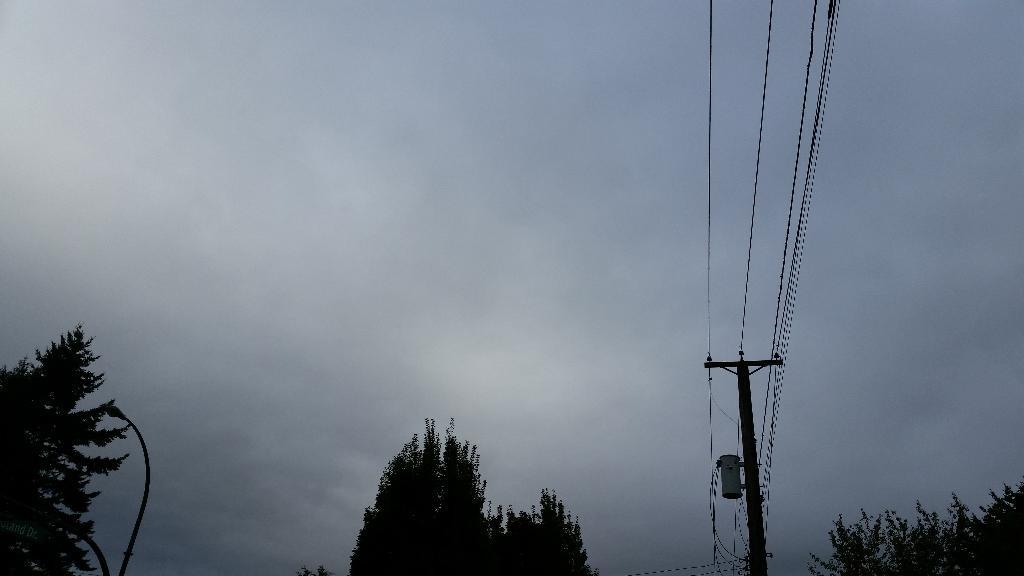What is located at the bottom of the image? There are trees and street lights at the bottom of the image. What can be found in the middle of the image? There is an electric pole and wires in the middle of the image. What is visible in the background of the image? The sky is visible in the background of the image. What type of error can be seen in the image? There is no error present in the image. What kind of stew is being prepared in the image? There is no stew or cooking activity depicted in the image. 